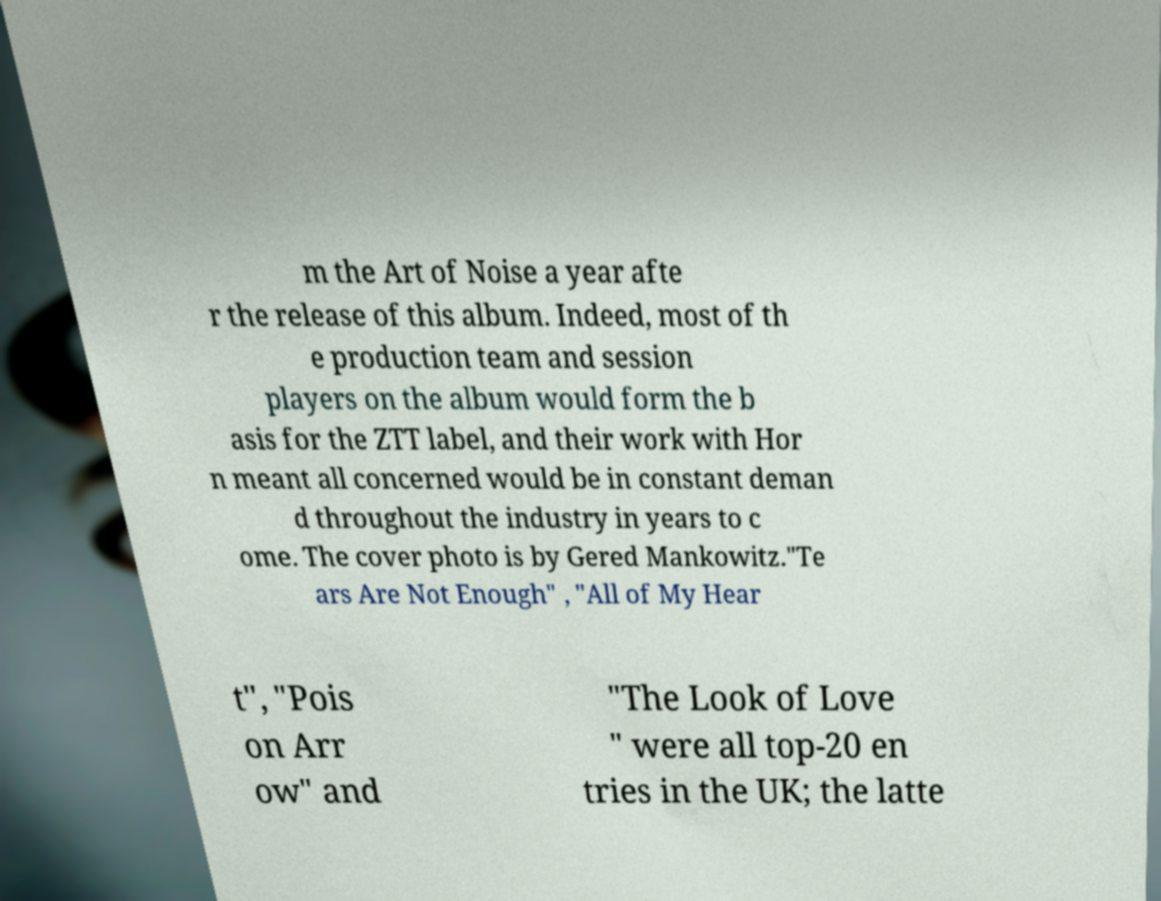For documentation purposes, I need the text within this image transcribed. Could you provide that? m the Art of Noise a year afte r the release of this album. Indeed, most of th e production team and session players on the album would form the b asis for the ZTT label, and their work with Hor n meant all concerned would be in constant deman d throughout the industry in years to c ome. The cover photo is by Gered Mankowitz."Te ars Are Not Enough" , "All of My Hear t", "Pois on Arr ow" and "The Look of Love " were all top-20 en tries in the UK; the latte 